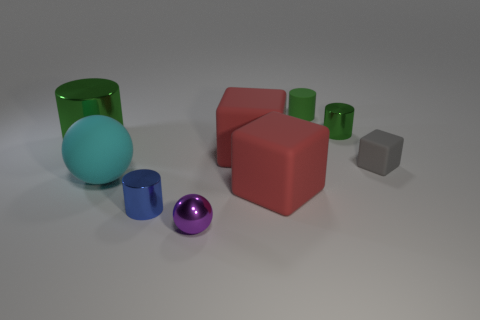Subtract all red matte blocks. How many blocks are left? 1 Subtract 1 spheres. How many spheres are left? 1 Subtract all red cylinders. How many red blocks are left? 2 Subtract all cyan spheres. How many spheres are left? 1 Subtract all cylinders. How many objects are left? 5 Subtract all blue balls. Subtract all green cubes. How many balls are left? 2 Subtract all big spheres. Subtract all green cylinders. How many objects are left? 5 Add 5 red objects. How many red objects are left? 7 Add 1 red metallic spheres. How many red metallic spheres exist? 1 Subtract 0 gray spheres. How many objects are left? 9 